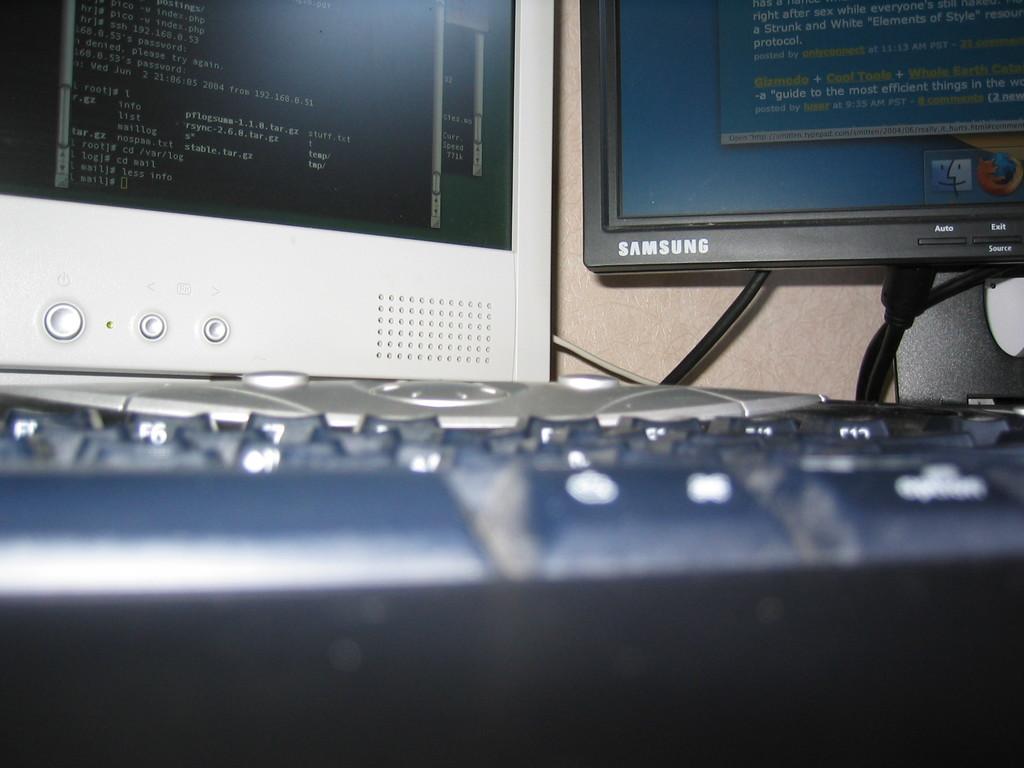Is that a samsung screen?
Provide a succinct answer. Yes. 